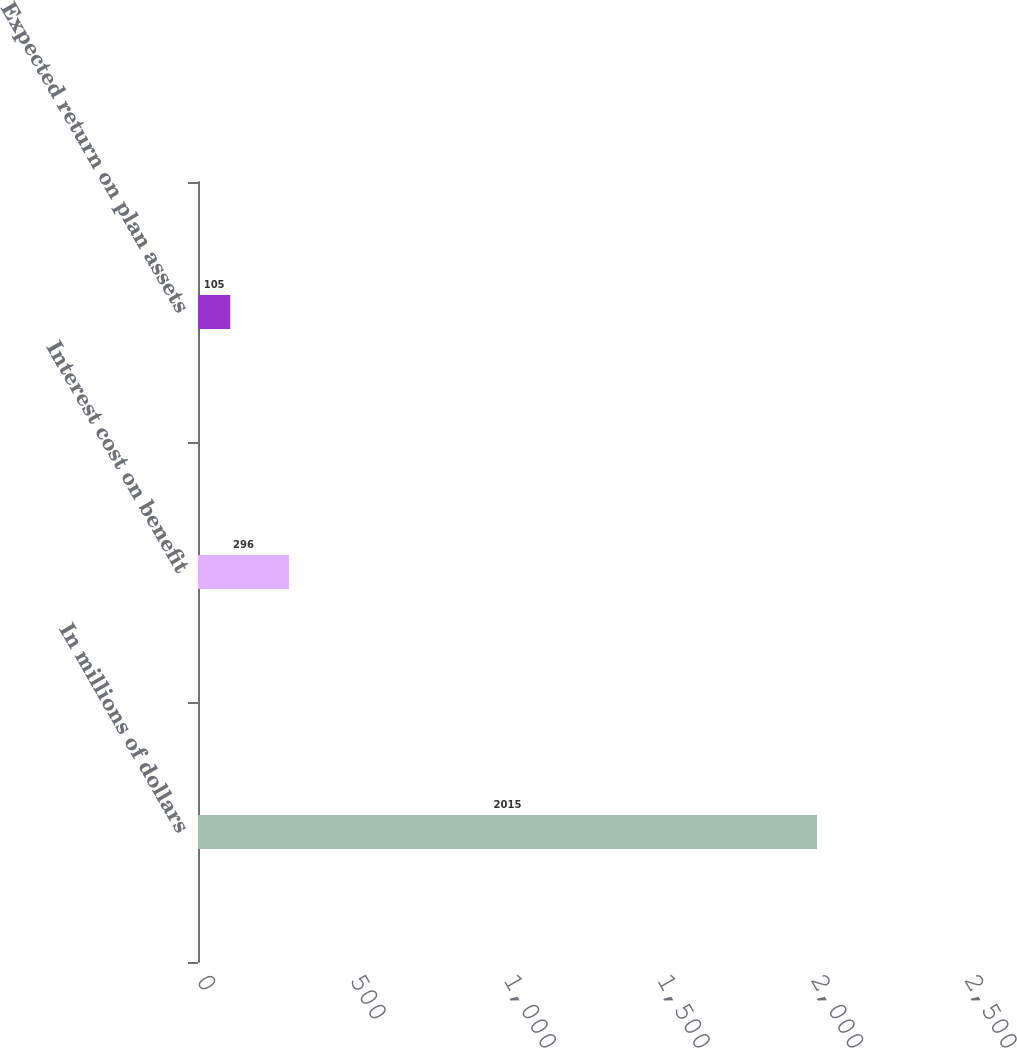<chart> <loc_0><loc_0><loc_500><loc_500><bar_chart><fcel>In millions of dollars<fcel>Interest cost on benefit<fcel>Expected return on plan assets<nl><fcel>2015<fcel>296<fcel>105<nl></chart> 